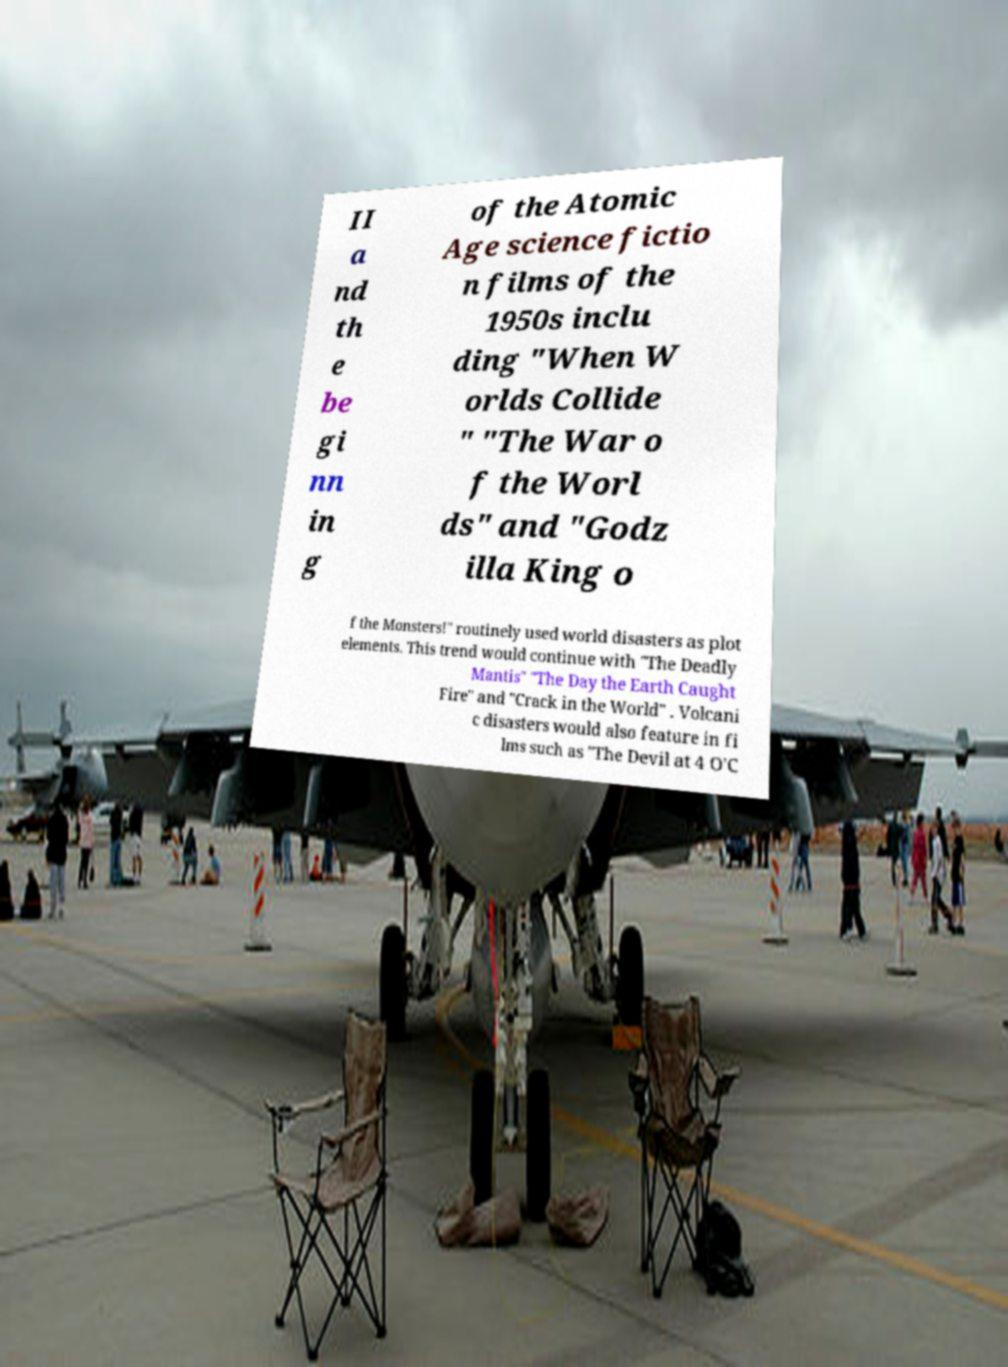There's text embedded in this image that I need extracted. Can you transcribe it verbatim? II a nd th e be gi nn in g of the Atomic Age science fictio n films of the 1950s inclu ding "When W orlds Collide " "The War o f the Worl ds" and "Godz illa King o f the Monsters!" routinely used world disasters as plot elements. This trend would continue with "The Deadly Mantis" "The Day the Earth Caught Fire" and "Crack in the World" . Volcani c disasters would also feature in fi lms such as "The Devil at 4 O'C 